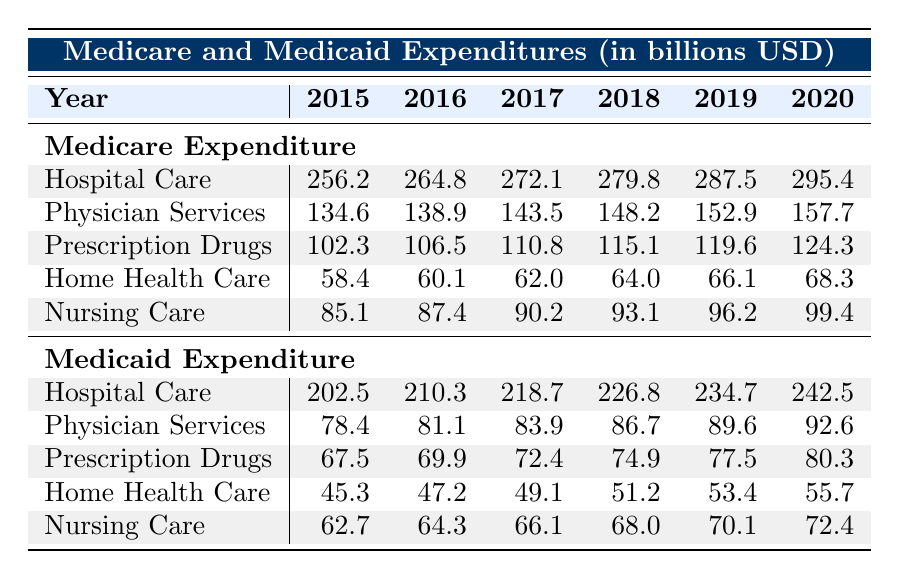What's the Medicare expenditure for Hospital Care in 2017? According to the table, the Medicare expenditure for Hospital Care in 2017 is specifically listed. By referring directly to that row, we see it is 272.1 billion USD.
Answer: 272.1 billion USD What was the total Medicare expenditure on Prescription Drugs from 2015 to 2020? To find the total, we need to sum the Prescription Drugs expenditures for each year: 102.3 + 106.5 + 110.8 + 115.1 + 119.6 + 124.3 = 778.6 billion USD.
Answer: 778.6 billion USD Has the Medicaid expenditure for Home Health Care increased every year from 2015 to 2020? By checking the values for each year in the Home Health Care row, we see the expenditures are 45.3, 47.2, 49.1, 51.2, 53.4, and 55.7 respectively; each is higher than the previous year. Therefore, it has increased every year.
Answer: Yes What is the difference in Medicare expenditures for Nursing Care between 2015 and 2020? We need to find the Medicare expenditures for Nursing Care in both years: in 2015 it was 85.1 billion USD and in 2020 it was 99.4 billion USD. The difference is 99.4 - 85.1 = 14.3 billion USD.
Answer: 14.3 billion USD In which year did Medicare expenditures on Physician Services surpass those of Medicaid expenditures? By comparing each year's Physician Services expenditures, we see that Medicare expenditures are consistently higher in every year shown from 2015 to 2020. Therefore, it first surpassed Medicaid in 2015 and remained higher.
Answer: 2015 What was the highest expenditure category for Medicare in 2018? By examining all categories for 2018, we find Hospital Care at 279.8 billion USD is higher than Physician Services (148.2), Prescription Drugs (115.1), Home Health Care (64.0), and Nursing Care (93.1). Hence, Hospital Care is the highest expenditure category.
Answer: Hospital Care 